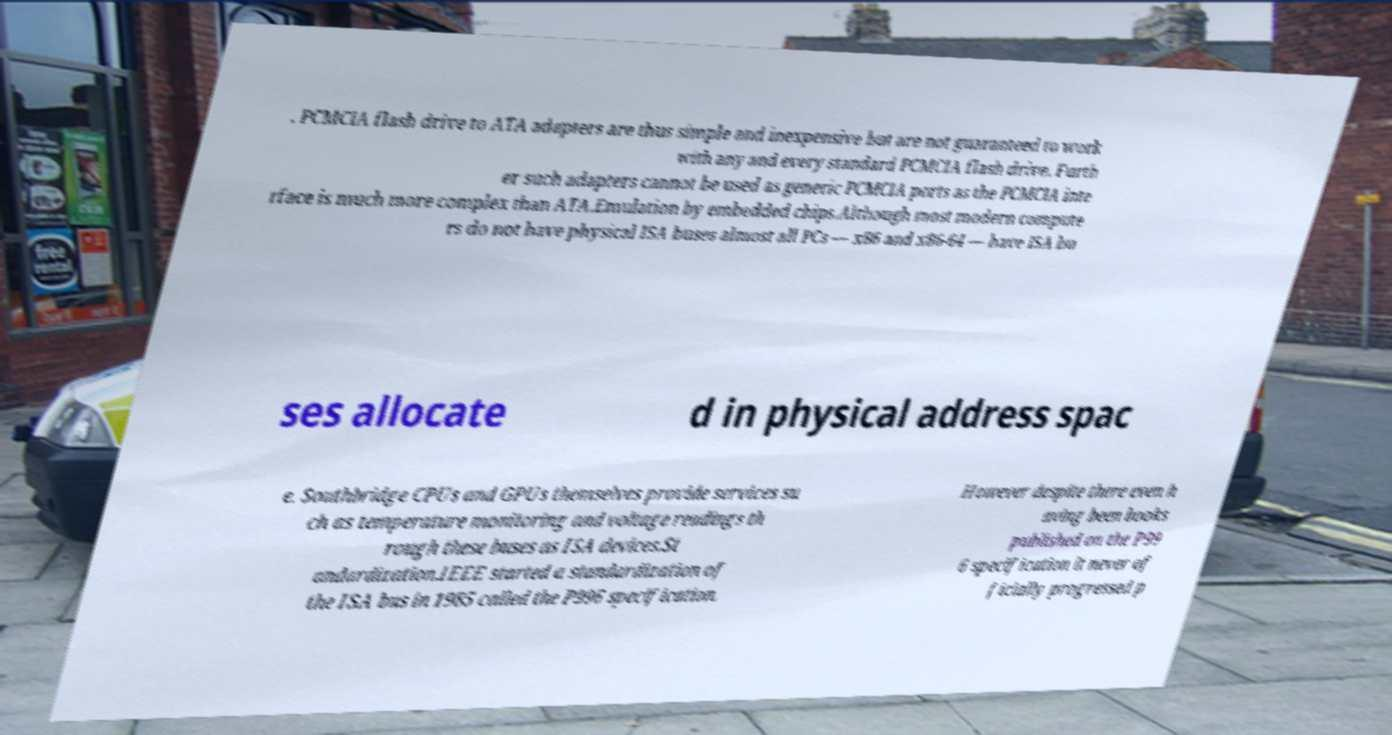Can you read and provide the text displayed in the image?This photo seems to have some interesting text. Can you extract and type it out for me? . PCMCIA flash drive to ATA adapters are thus simple and inexpensive but are not guaranteed to work with any and every standard PCMCIA flash drive. Furth er such adapters cannot be used as generic PCMCIA ports as the PCMCIA inte rface is much more complex than ATA.Emulation by embedded chips.Although most modern compute rs do not have physical ISA buses almost all PCs — x86 and x86-64 — have ISA bu ses allocate d in physical address spac e. Southbridge CPUs and GPUs themselves provide services su ch as temperature monitoring and voltage readings th rough these buses as ISA devices.St andardization.IEEE started a standardization of the ISA bus in 1985 called the P996 specification. However despite there even h aving been books published on the P99 6 specification it never of ficially progressed p 